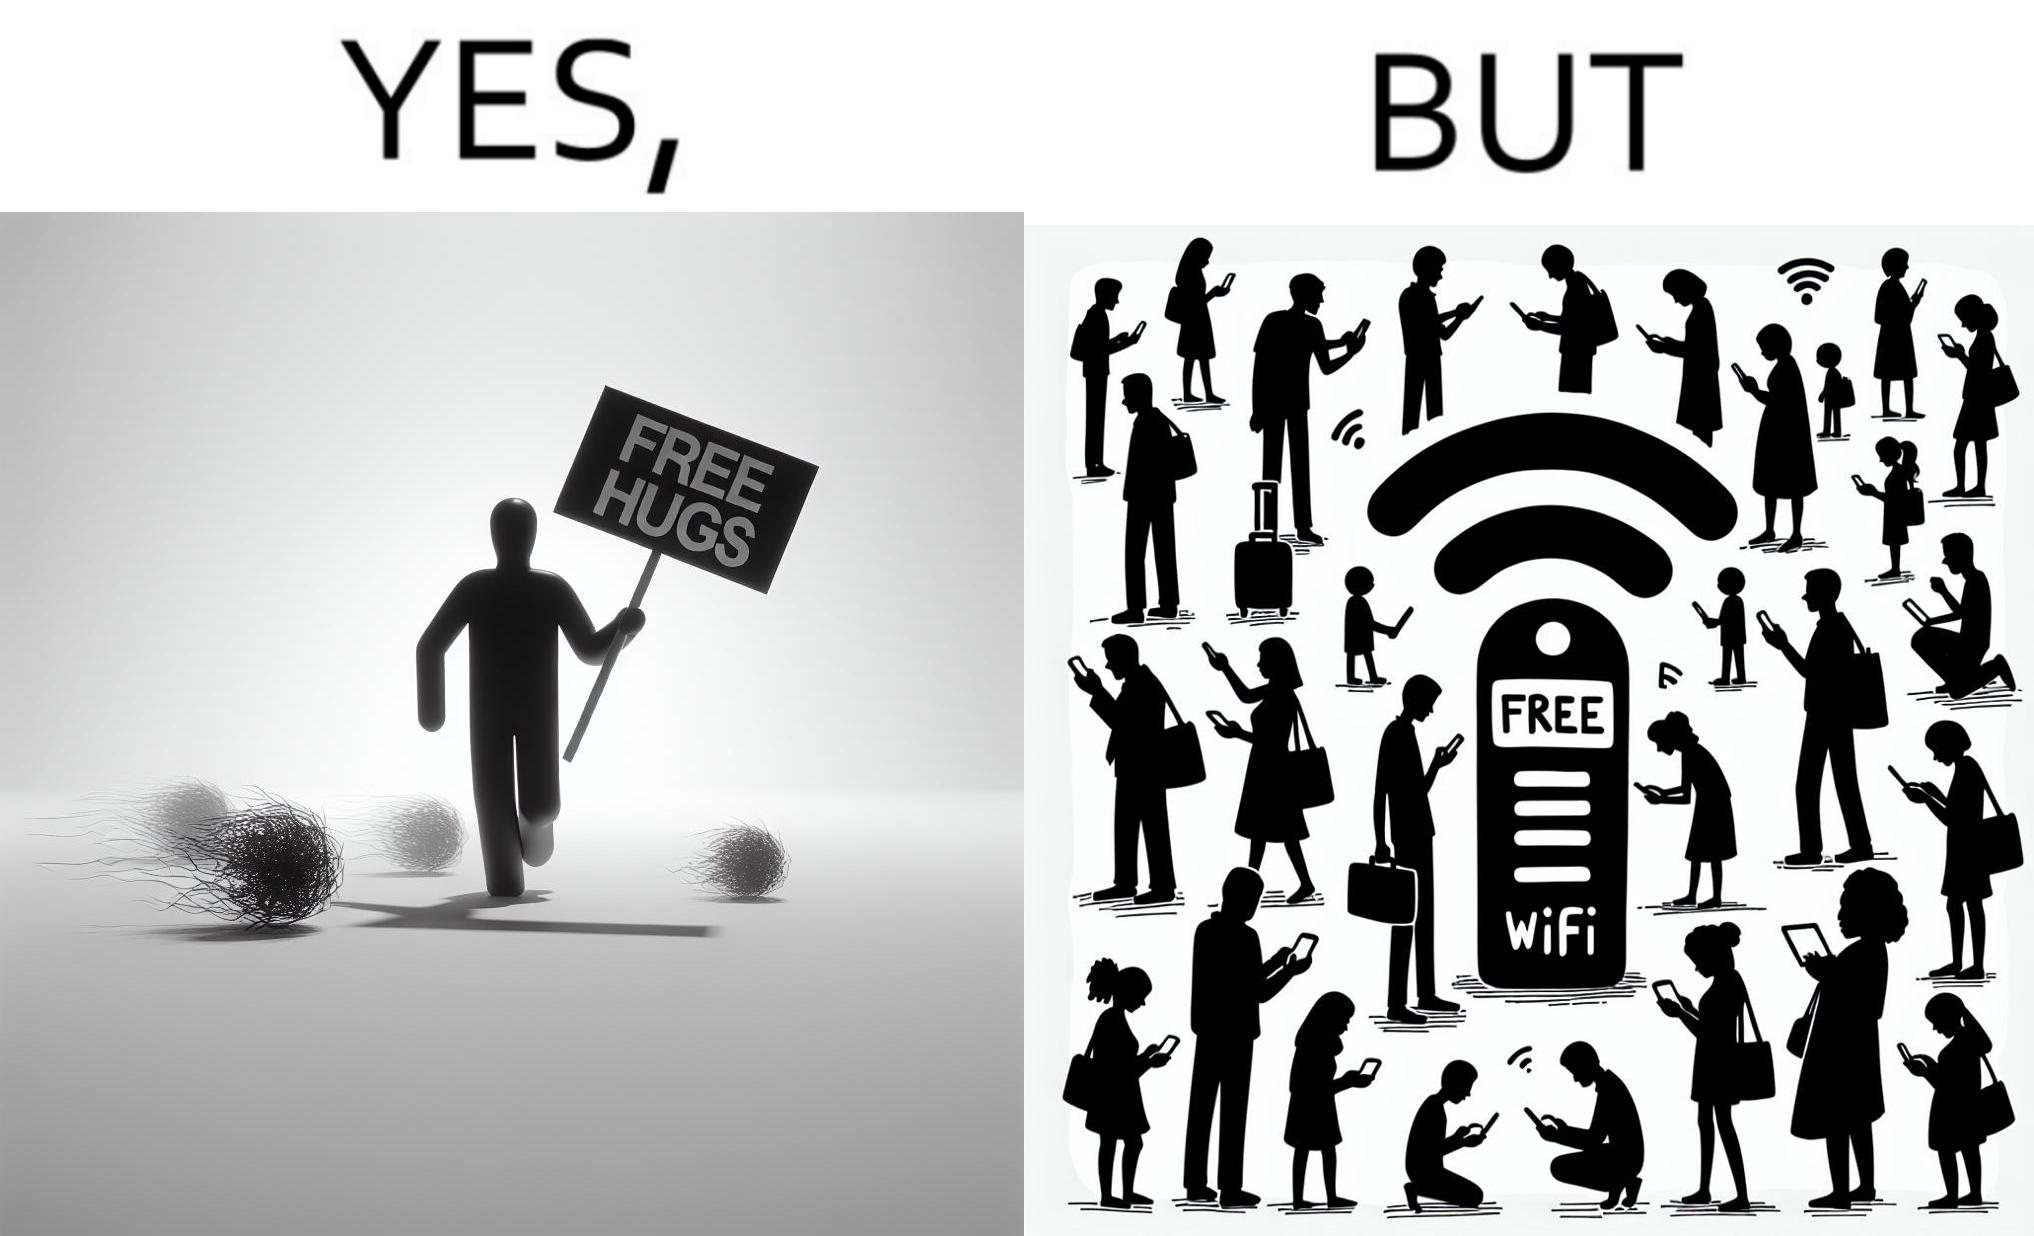Is this a satirical image? Yes, this image is satirical. 